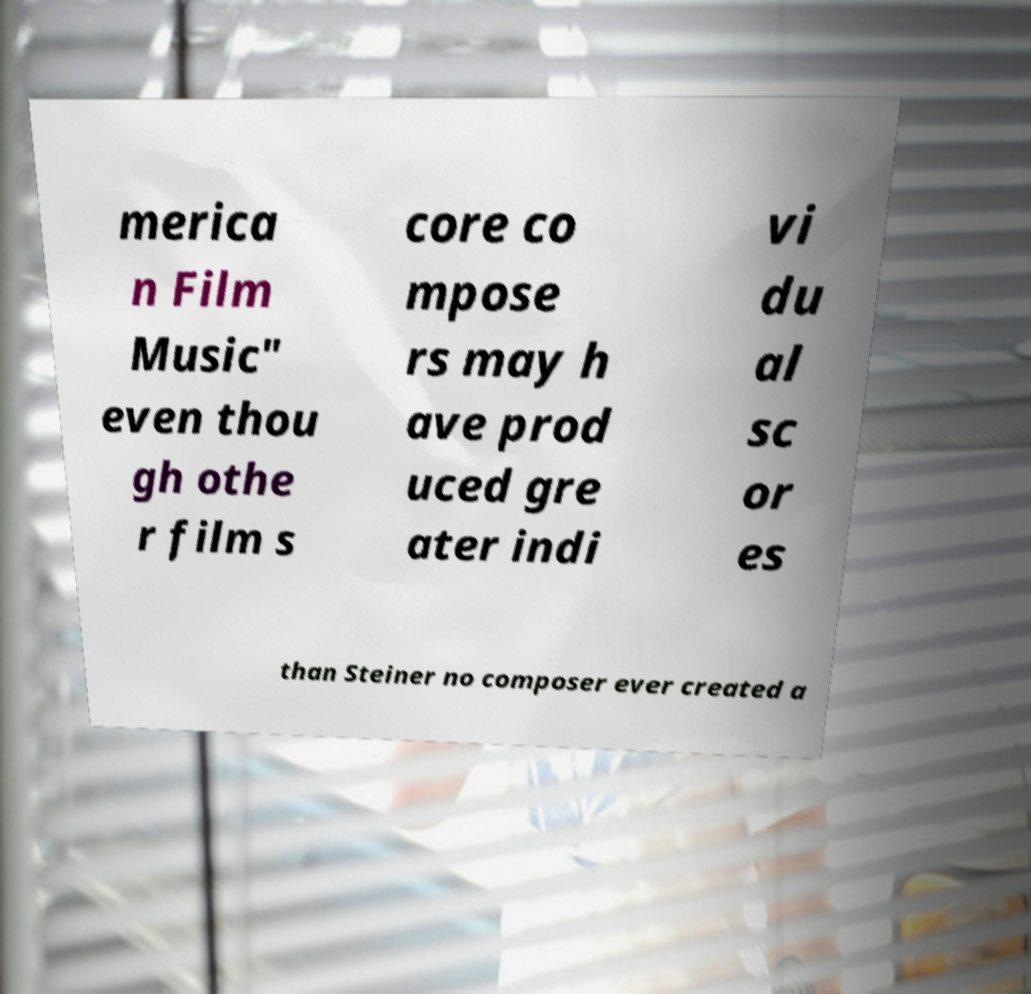What messages or text are displayed in this image? I need them in a readable, typed format. merica n Film Music" even thou gh othe r film s core co mpose rs may h ave prod uced gre ater indi vi du al sc or es than Steiner no composer ever created a 